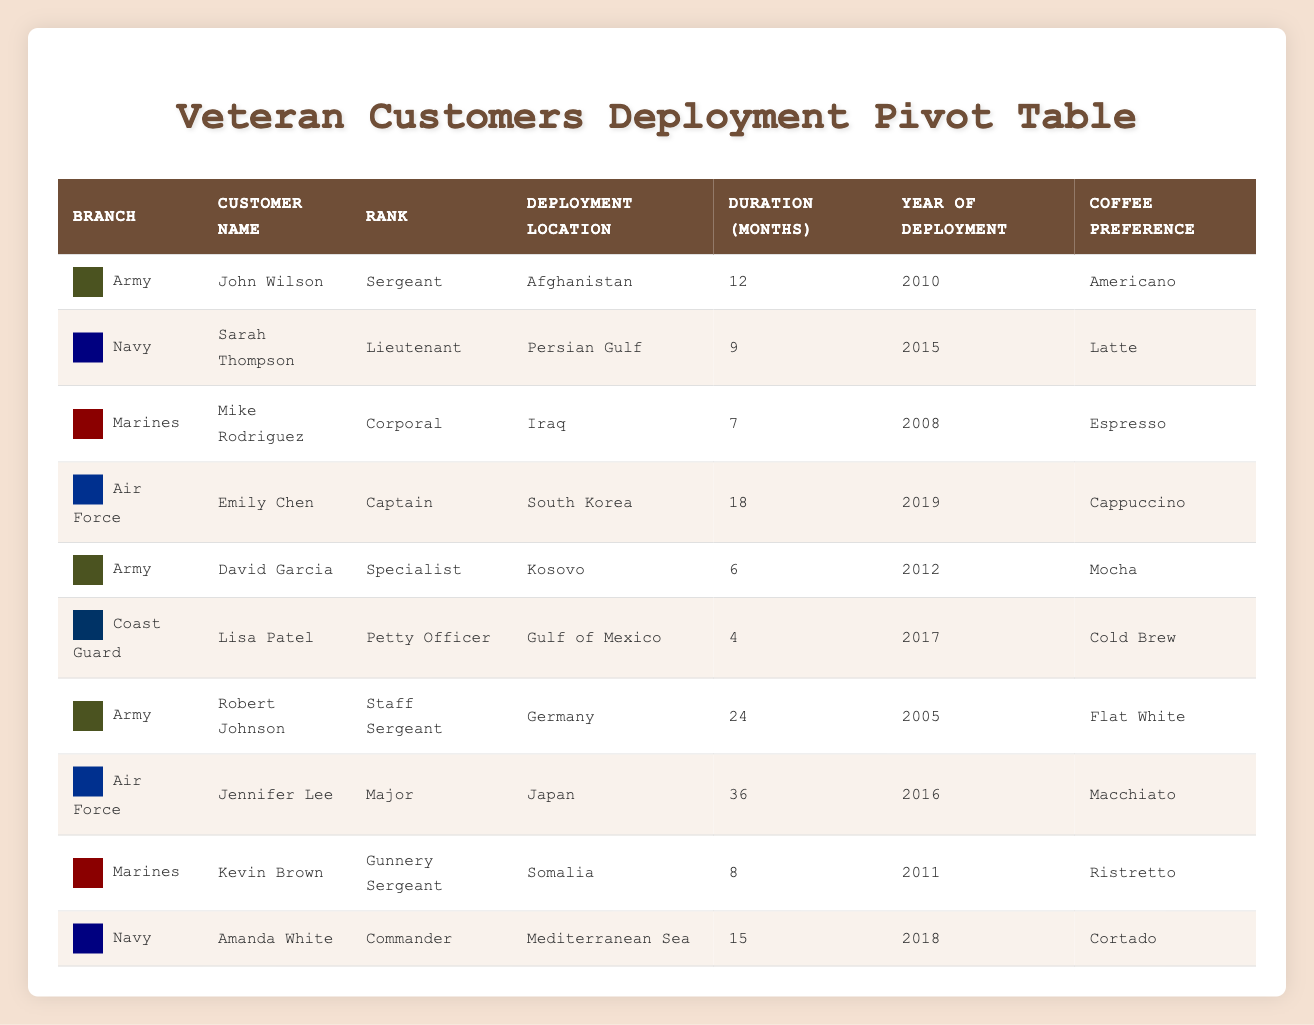What is the total duration of deployment for all customers in the Navy? To find the total duration for Navy customers, I check each entry for the Navy branch and add their durations together. The durations are 9 months (Sarah Thompson), 15 months (Amanda White), so the total is 9 + 15 = 24 months.
Answer: 24 months Which customer has the longest deployment duration and how long was it? I look through the deployment durations for all customers. The longest duration found is 36 months, which belongs to Jennifer Lee from the Air Force.
Answer: Jennifer Lee, 36 months Is there a customer who deployed to Iraq? I scan the deployment locations in the table to see if Iraq is listed. I find Mike Rodriguez listed as having deployed to Iraq. Therefore, the answer is yes.
Answer: Yes What is the average deployment duration for customers in the Army? To compute the average, I first check all Army customers: John Wilson (12 months), David Garcia (6 months), and Robert Johnson (24 months). Their total duration is 12 + 6 + 24 = 42 months. There are 3 Army customers, so the average is 42/3 = 14 months.
Answer: 14 months How many customers deployed for less than 10 months? I compare all durations in the table, identifying those below 10 months. I find that Mike Rodriguez (7 months), David Garcia (6 months), and Lisa Patel (4 months) fit this criterion. Thus, there are 3 customers who deployed for less than 10 months.
Answer: 3 customers Which branch had the customer with the lowest coffee preference rating? I look at the coffee preferences in the table. All preferences are unique, but I assume "Cold Brew" is generally considered less popular than others in a veteran context. Lisa Patel with the Coast Guard has this preference, making her branch the winner for this question.
Answer: Coast Guard How many customers served in the Marines, and what was their average deployment duration? I identify two customers in the Marines: Mike Rodriguez (7 months) and Kevin Brown (8 months). Their total duration is 7 + 8 = 15 months, and the average, divided by 2, equals 15/2 = 7.5 months.
Answer: 2 customers, 7.5 months Did any Air Force customer deploy for more than 20 months? I find the durations of the Air Force customers: Emily Chen (18 months) and Jennifer Lee (36 months). Since 36 months is greater than 20, the answer is yes.
Answer: Yes 